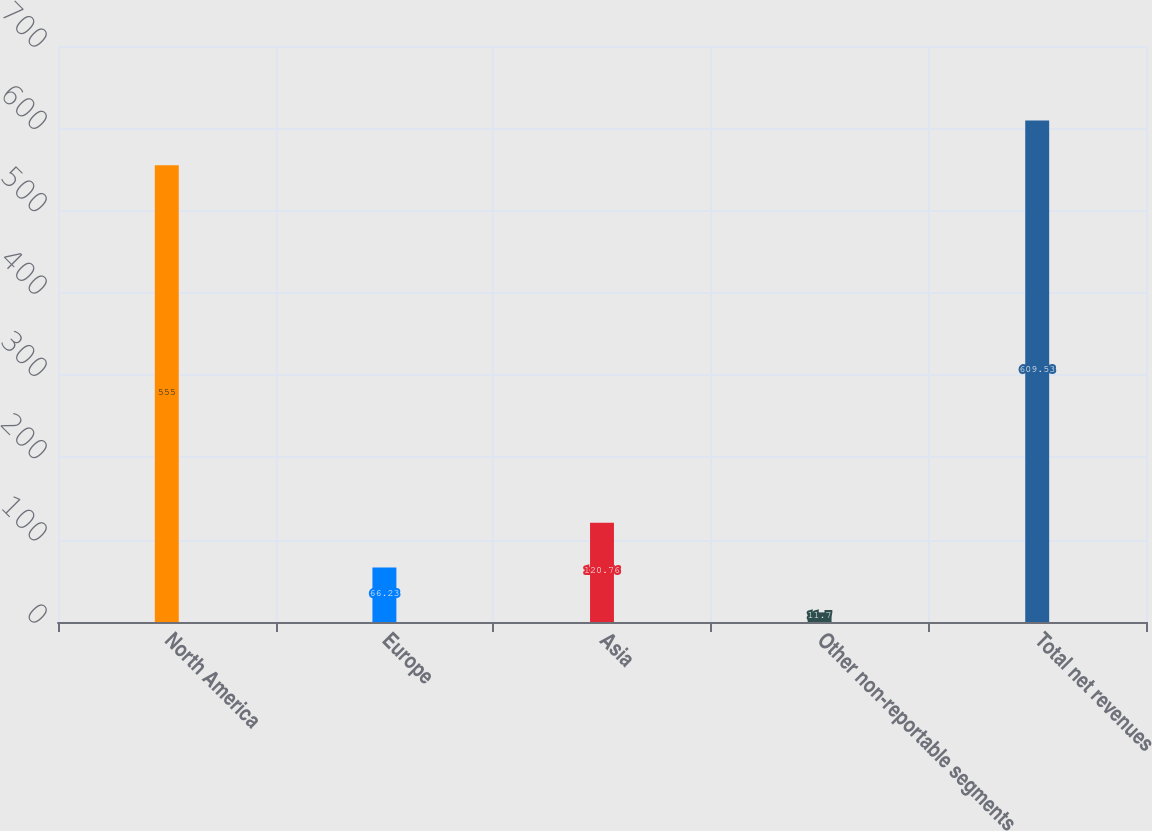Convert chart to OTSL. <chart><loc_0><loc_0><loc_500><loc_500><bar_chart><fcel>North America<fcel>Europe<fcel>Asia<fcel>Other non-reportable segments<fcel>Total net revenues<nl><fcel>555<fcel>66.23<fcel>120.76<fcel>11.7<fcel>609.53<nl></chart> 